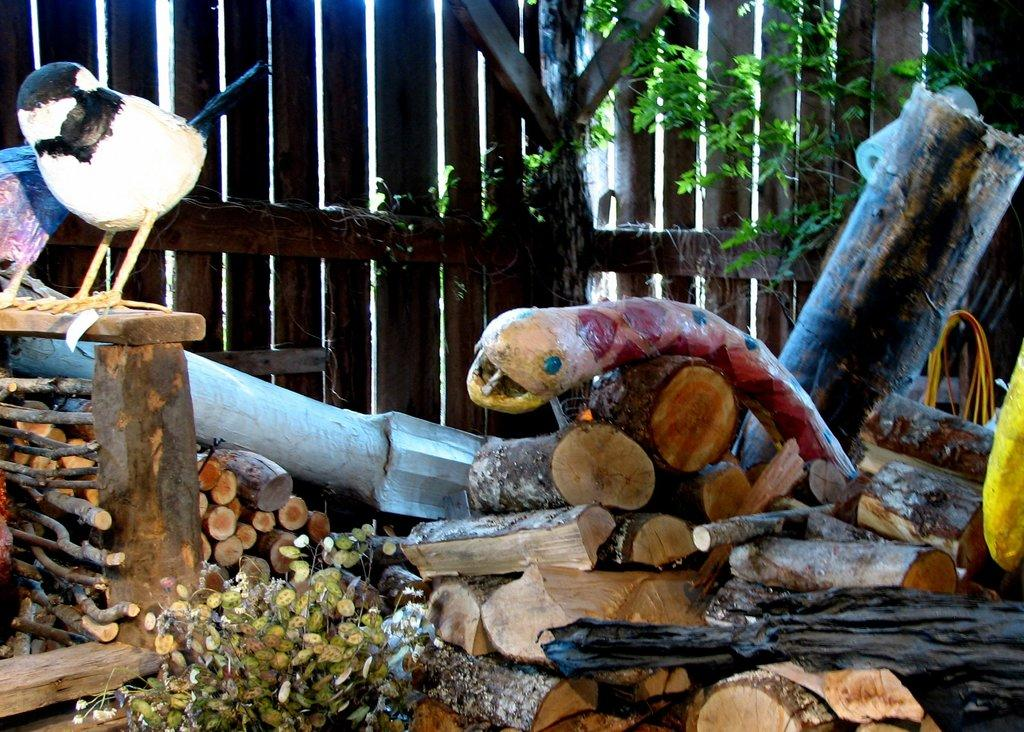What type of objects are made of wood in the image? There are wooden sticks and a wooden fence in the image. What kind of animal is represented by the toy in the image? There is a toy bird in the image. What type of vegetation can be seen in the image? There are plants and creepers in the image. What other object can be seen in the image that is not made of wood? There is a rope in the image. What type of tax is being discussed in the image? There is no mention of tax in the image; it features trunks, wooden sticks, a toy bird, a wooden fence, plants, creepers, and a rope. What kind of test is being conducted in the image? There is no test being conducted in the image; it features various objects and vegetation. 